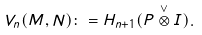<formula> <loc_0><loc_0><loc_500><loc_500>V _ { n } ( M , N ) \colon = H _ { n + 1 } ( P \overset { \vee } { \otimes } I ) .</formula> 